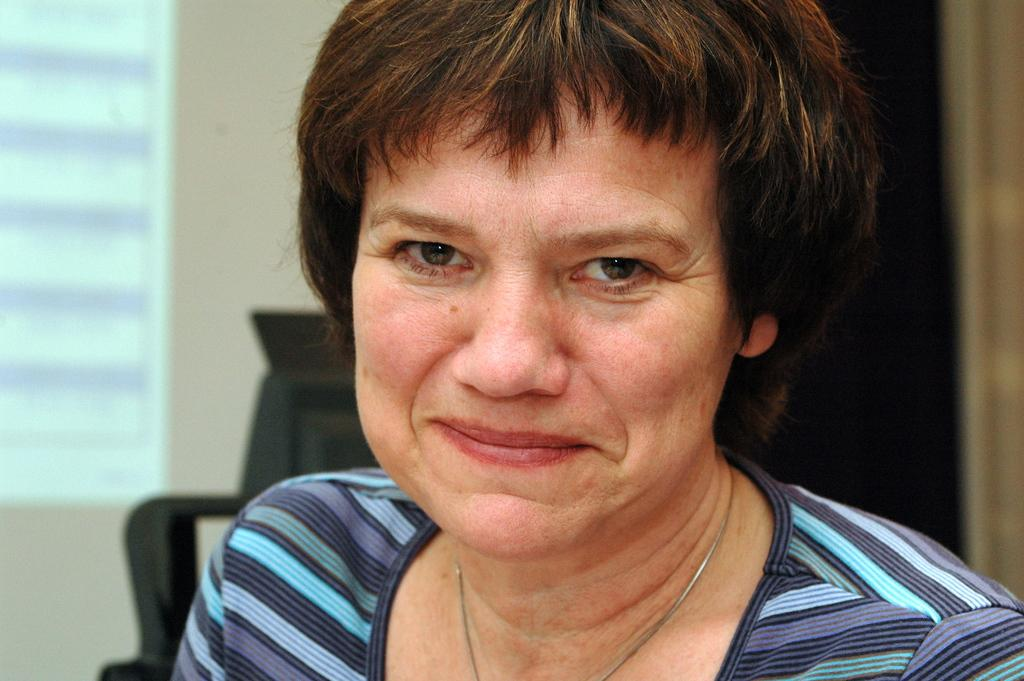Who is present in the image? There is a woman in the image. What can be seen in the background of the image? There is an object, a wall, and a window in the background of the image. What type of impulse can be seen affecting the woman in the image? There is no indication of any impulse affecting the woman in the image. Can you describe the bite marks on the woman in the image? There are no bite marks visible on the woman in the image. 